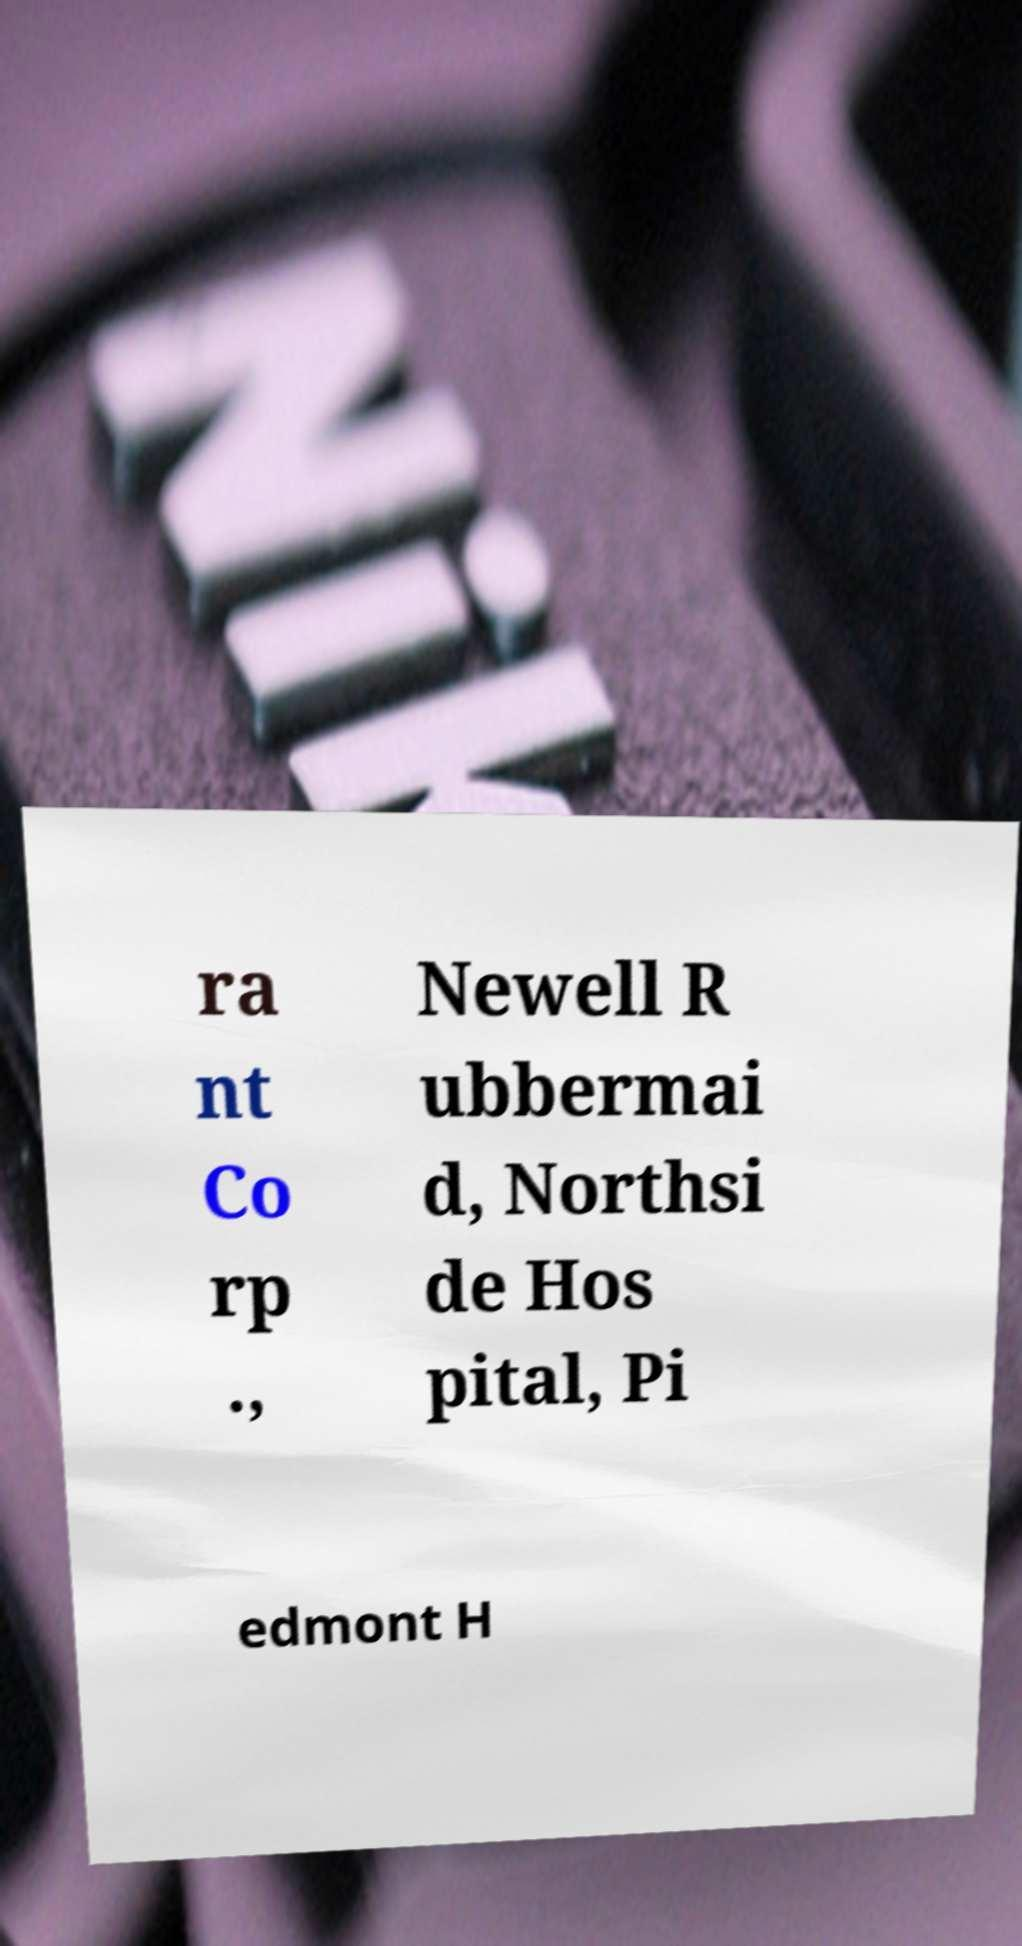Please identify and transcribe the text found in this image. ra nt Co rp ., Newell R ubbermai d, Northsi de Hos pital, Pi edmont H 